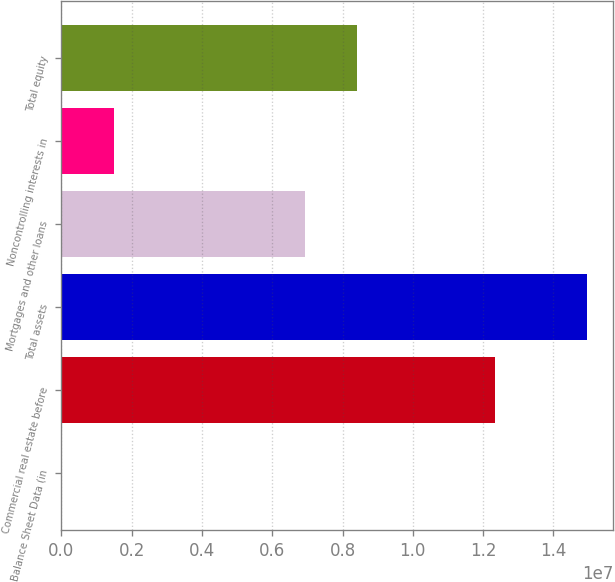Convert chart. <chart><loc_0><loc_0><loc_500><loc_500><bar_chart><fcel>Balance Sheet Data (in<fcel>Commercial real estate before<fcel>Total assets<fcel>Mortgages and other loans<fcel>Noncontrolling interests in<fcel>Total equity<nl><fcel>2013<fcel>1.23338e+07<fcel>1.4959e+07<fcel>6.91991e+06<fcel>1.49771e+06<fcel>8.41561e+06<nl></chart> 